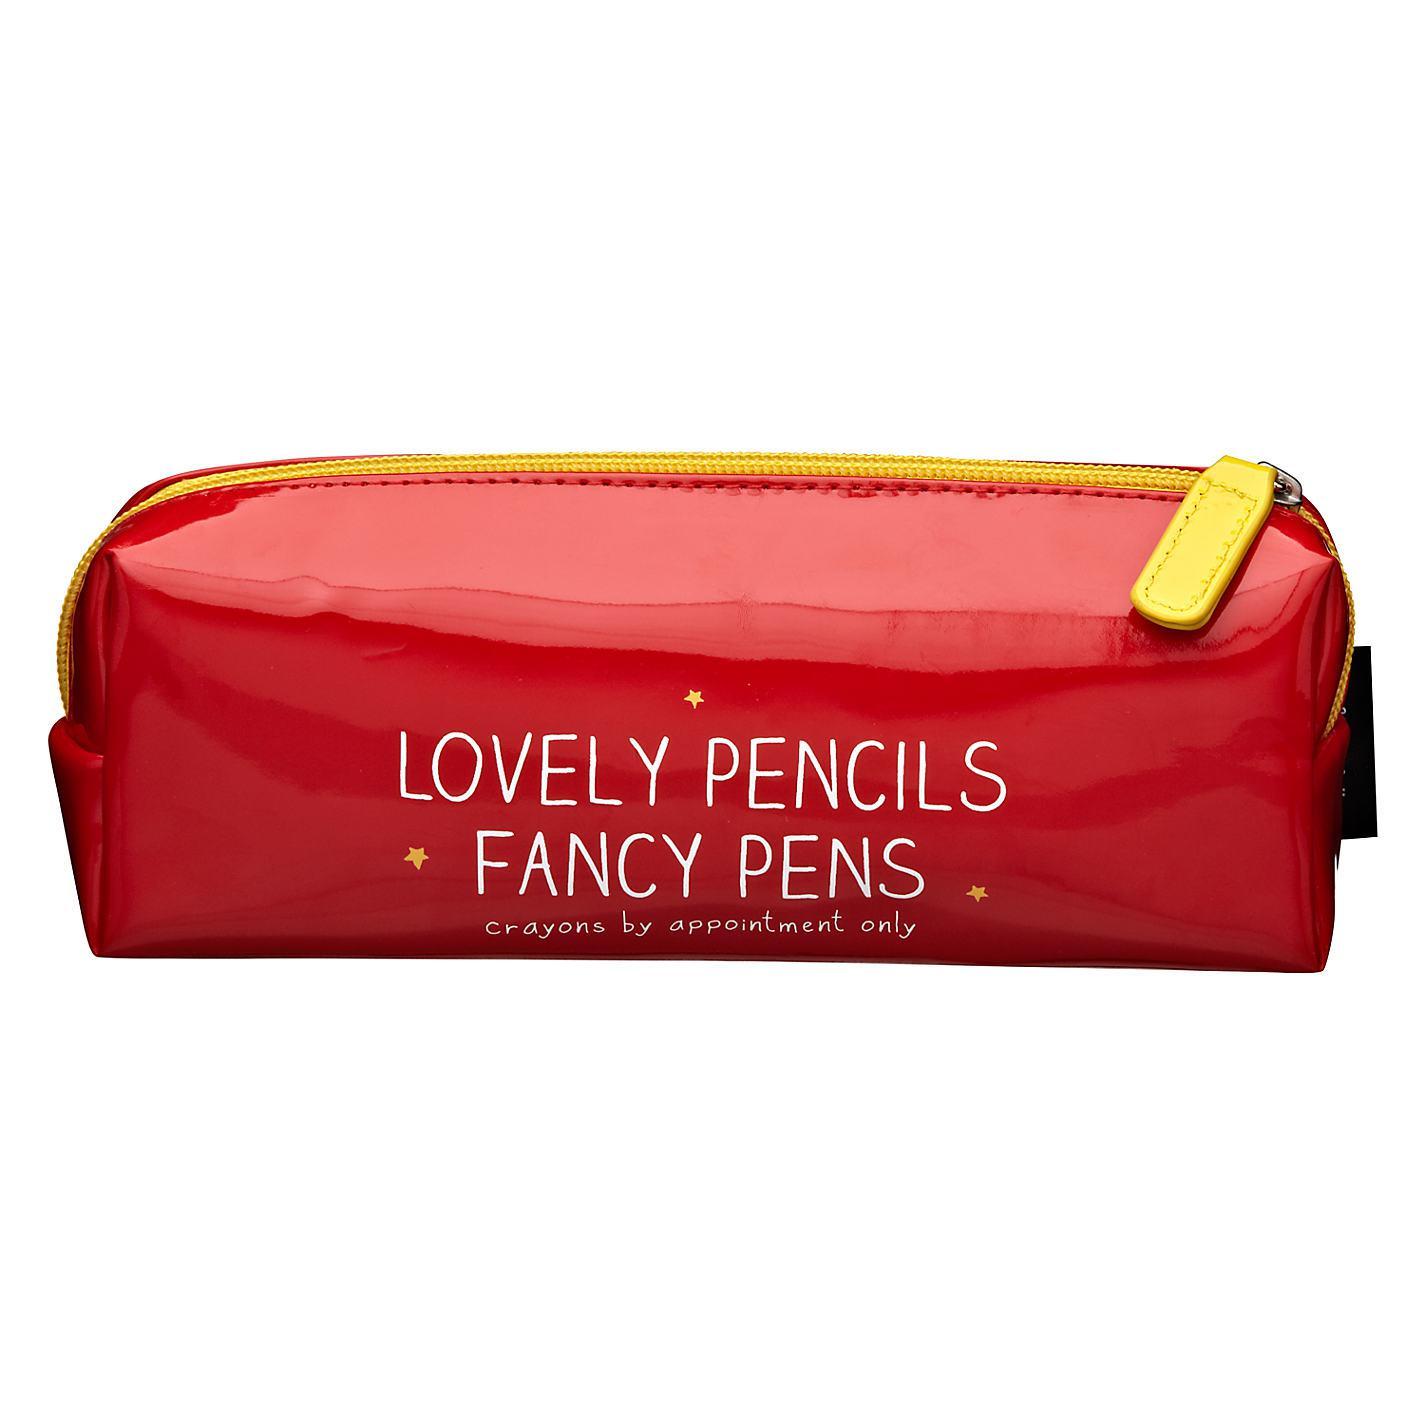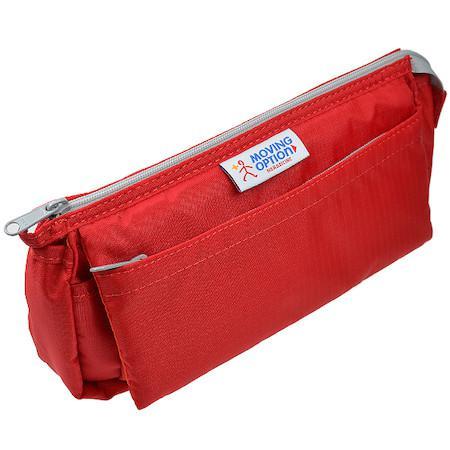The first image is the image on the left, the second image is the image on the right. Analyze the images presented: Is the assertion "The pencil case on the left is not flat; it's shaped more like a rectangular box." valid? Answer yes or no. Yes. The first image is the image on the left, the second image is the image on the right. Evaluate the accuracy of this statement regarding the images: "There is one brand label showing on the pencil pouch on the right.". Is it true? Answer yes or no. Yes. 